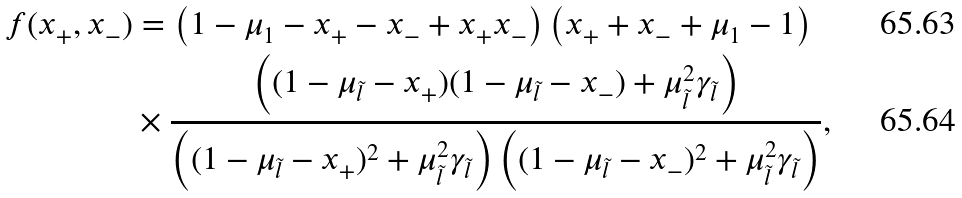Convert formula to latex. <formula><loc_0><loc_0><loc_500><loc_500>f ( x _ { + } , x _ { - } ) & = \left ( 1 - \mu _ { 1 } - x _ { + } - x _ { - } + x _ { + } x _ { - } \right ) \left ( x _ { + } + x _ { - } + \mu _ { 1 } - 1 \right ) \\ & \times \frac { \left ( ( 1 - \mu _ { \tilde { l } } - x _ { + } ) ( 1 - \mu _ { \tilde { l } } - x _ { - } ) + \mu _ { \tilde { l } } ^ { 2 } \gamma _ { \tilde { l } } \right ) } { \left ( ( 1 - \mu _ { \tilde { l } } - x _ { + } ) ^ { 2 } + \mu _ { \tilde { l } } ^ { 2 } \gamma _ { \tilde { l } } \right ) \left ( ( 1 - \mu _ { \tilde { l } } - x _ { - } ) ^ { 2 } + \mu _ { \tilde { l } } ^ { 2 } \gamma _ { \tilde { l } } \right ) } ,</formula> 